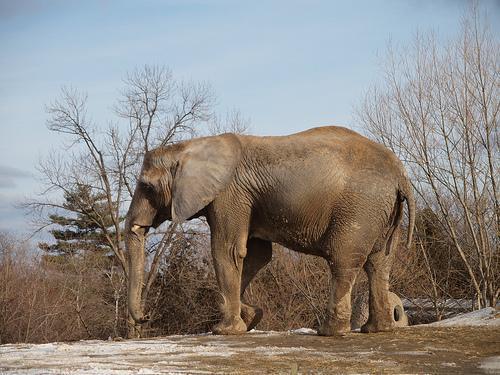How many elephants are there?
Give a very brief answer. 1. 